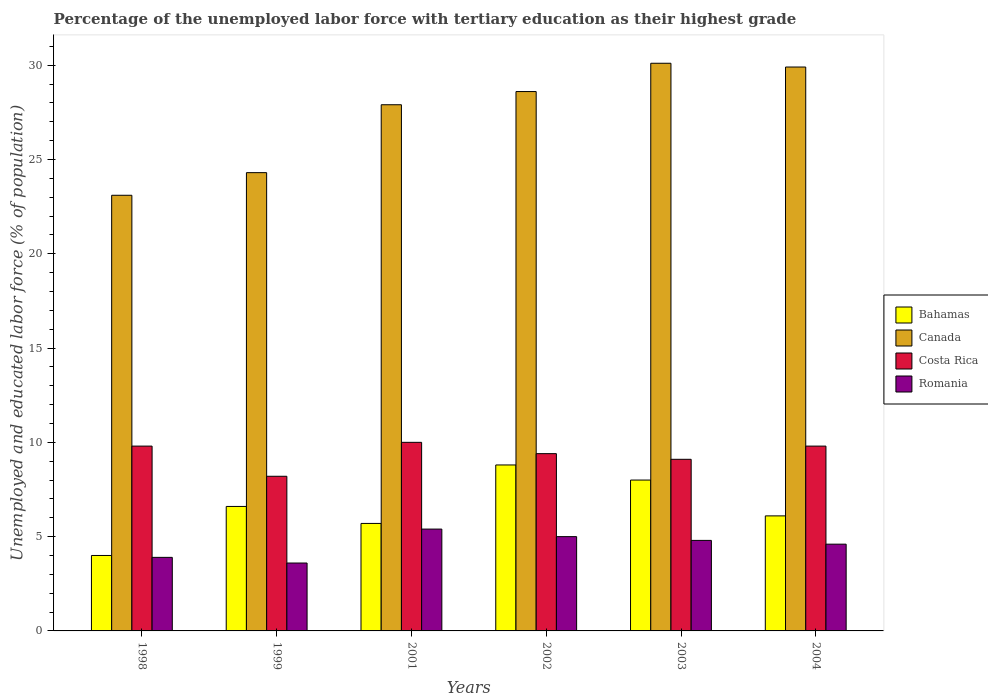How many groups of bars are there?
Your answer should be compact. 6. How many bars are there on the 2nd tick from the left?
Ensure brevity in your answer.  4. What is the label of the 3rd group of bars from the left?
Keep it short and to the point. 2001. In how many cases, is the number of bars for a given year not equal to the number of legend labels?
Offer a very short reply. 0. What is the percentage of the unemployed labor force with tertiary education in Canada in 2004?
Your answer should be very brief. 29.9. Across all years, what is the maximum percentage of the unemployed labor force with tertiary education in Canada?
Make the answer very short. 30.1. Across all years, what is the minimum percentage of the unemployed labor force with tertiary education in Romania?
Provide a succinct answer. 3.6. In which year was the percentage of the unemployed labor force with tertiary education in Romania minimum?
Your answer should be very brief. 1999. What is the total percentage of the unemployed labor force with tertiary education in Costa Rica in the graph?
Ensure brevity in your answer.  56.3. What is the difference between the percentage of the unemployed labor force with tertiary education in Costa Rica in 1998 and that in 1999?
Offer a very short reply. 1.6. What is the difference between the percentage of the unemployed labor force with tertiary education in Romania in 2001 and the percentage of the unemployed labor force with tertiary education in Costa Rica in 2002?
Your answer should be compact. -4. What is the average percentage of the unemployed labor force with tertiary education in Bahamas per year?
Offer a terse response. 6.53. In the year 2002, what is the difference between the percentage of the unemployed labor force with tertiary education in Bahamas and percentage of the unemployed labor force with tertiary education in Canada?
Your response must be concise. -19.8. In how many years, is the percentage of the unemployed labor force with tertiary education in Bahamas greater than 23 %?
Provide a short and direct response. 0. What is the ratio of the percentage of the unemployed labor force with tertiary education in Bahamas in 1998 to that in 2004?
Your response must be concise. 0.66. Is the percentage of the unemployed labor force with tertiary education in Bahamas in 1998 less than that in 2001?
Offer a very short reply. Yes. Is the difference between the percentage of the unemployed labor force with tertiary education in Bahamas in 1998 and 2003 greater than the difference between the percentage of the unemployed labor force with tertiary education in Canada in 1998 and 2003?
Provide a short and direct response. Yes. What is the difference between the highest and the second highest percentage of the unemployed labor force with tertiary education in Romania?
Offer a terse response. 0.4. What is the difference between the highest and the lowest percentage of the unemployed labor force with tertiary education in Costa Rica?
Provide a succinct answer. 1.8. Is the sum of the percentage of the unemployed labor force with tertiary education in Canada in 1999 and 2001 greater than the maximum percentage of the unemployed labor force with tertiary education in Bahamas across all years?
Provide a succinct answer. Yes. Is it the case that in every year, the sum of the percentage of the unemployed labor force with tertiary education in Costa Rica and percentage of the unemployed labor force with tertiary education in Canada is greater than the sum of percentage of the unemployed labor force with tertiary education in Bahamas and percentage of the unemployed labor force with tertiary education in Romania?
Your answer should be compact. No. What does the 1st bar from the left in 2001 represents?
Your answer should be compact. Bahamas. What does the 3rd bar from the right in 1998 represents?
Offer a very short reply. Canada. Is it the case that in every year, the sum of the percentage of the unemployed labor force with tertiary education in Costa Rica and percentage of the unemployed labor force with tertiary education in Bahamas is greater than the percentage of the unemployed labor force with tertiary education in Romania?
Your response must be concise. Yes. How many years are there in the graph?
Your answer should be very brief. 6. What is the difference between two consecutive major ticks on the Y-axis?
Provide a short and direct response. 5. Does the graph contain any zero values?
Your answer should be very brief. No. How many legend labels are there?
Your answer should be compact. 4. What is the title of the graph?
Keep it short and to the point. Percentage of the unemployed labor force with tertiary education as their highest grade. What is the label or title of the Y-axis?
Your answer should be compact. Unemployed and educated labor force (% of population). What is the Unemployed and educated labor force (% of population) in Bahamas in 1998?
Offer a terse response. 4. What is the Unemployed and educated labor force (% of population) in Canada in 1998?
Make the answer very short. 23.1. What is the Unemployed and educated labor force (% of population) of Costa Rica in 1998?
Your response must be concise. 9.8. What is the Unemployed and educated labor force (% of population) in Romania in 1998?
Give a very brief answer. 3.9. What is the Unemployed and educated labor force (% of population) of Bahamas in 1999?
Provide a succinct answer. 6.6. What is the Unemployed and educated labor force (% of population) in Canada in 1999?
Provide a short and direct response. 24.3. What is the Unemployed and educated labor force (% of population) in Costa Rica in 1999?
Provide a succinct answer. 8.2. What is the Unemployed and educated labor force (% of population) of Romania in 1999?
Your answer should be very brief. 3.6. What is the Unemployed and educated labor force (% of population) of Bahamas in 2001?
Ensure brevity in your answer.  5.7. What is the Unemployed and educated labor force (% of population) in Canada in 2001?
Ensure brevity in your answer.  27.9. What is the Unemployed and educated labor force (% of population) in Romania in 2001?
Keep it short and to the point. 5.4. What is the Unemployed and educated labor force (% of population) of Bahamas in 2002?
Your answer should be compact. 8.8. What is the Unemployed and educated labor force (% of population) of Canada in 2002?
Provide a succinct answer. 28.6. What is the Unemployed and educated labor force (% of population) in Costa Rica in 2002?
Provide a short and direct response. 9.4. What is the Unemployed and educated labor force (% of population) of Canada in 2003?
Make the answer very short. 30.1. What is the Unemployed and educated labor force (% of population) in Costa Rica in 2003?
Give a very brief answer. 9.1. What is the Unemployed and educated labor force (% of population) of Romania in 2003?
Ensure brevity in your answer.  4.8. What is the Unemployed and educated labor force (% of population) of Bahamas in 2004?
Ensure brevity in your answer.  6.1. What is the Unemployed and educated labor force (% of population) of Canada in 2004?
Your response must be concise. 29.9. What is the Unemployed and educated labor force (% of population) in Costa Rica in 2004?
Make the answer very short. 9.8. What is the Unemployed and educated labor force (% of population) in Romania in 2004?
Your response must be concise. 4.6. Across all years, what is the maximum Unemployed and educated labor force (% of population) in Bahamas?
Your response must be concise. 8.8. Across all years, what is the maximum Unemployed and educated labor force (% of population) in Canada?
Provide a short and direct response. 30.1. Across all years, what is the maximum Unemployed and educated labor force (% of population) of Romania?
Make the answer very short. 5.4. Across all years, what is the minimum Unemployed and educated labor force (% of population) in Bahamas?
Your answer should be very brief. 4. Across all years, what is the minimum Unemployed and educated labor force (% of population) of Canada?
Make the answer very short. 23.1. Across all years, what is the minimum Unemployed and educated labor force (% of population) in Costa Rica?
Provide a short and direct response. 8.2. Across all years, what is the minimum Unemployed and educated labor force (% of population) in Romania?
Your response must be concise. 3.6. What is the total Unemployed and educated labor force (% of population) of Bahamas in the graph?
Provide a succinct answer. 39.2. What is the total Unemployed and educated labor force (% of population) of Canada in the graph?
Give a very brief answer. 163.9. What is the total Unemployed and educated labor force (% of population) of Costa Rica in the graph?
Provide a short and direct response. 56.3. What is the total Unemployed and educated labor force (% of population) in Romania in the graph?
Make the answer very short. 27.3. What is the difference between the Unemployed and educated labor force (% of population) of Bahamas in 1998 and that in 1999?
Your answer should be compact. -2.6. What is the difference between the Unemployed and educated labor force (% of population) in Canada in 1998 and that in 1999?
Offer a terse response. -1.2. What is the difference between the Unemployed and educated labor force (% of population) of Costa Rica in 1998 and that in 1999?
Provide a short and direct response. 1.6. What is the difference between the Unemployed and educated labor force (% of population) of Romania in 1998 and that in 1999?
Provide a succinct answer. 0.3. What is the difference between the Unemployed and educated labor force (% of population) of Bahamas in 1998 and that in 2001?
Ensure brevity in your answer.  -1.7. What is the difference between the Unemployed and educated labor force (% of population) in Canada in 1998 and that in 2001?
Give a very brief answer. -4.8. What is the difference between the Unemployed and educated labor force (% of population) of Romania in 1998 and that in 2001?
Give a very brief answer. -1.5. What is the difference between the Unemployed and educated labor force (% of population) in Costa Rica in 1998 and that in 2003?
Make the answer very short. 0.7. What is the difference between the Unemployed and educated labor force (% of population) in Romania in 1998 and that in 2003?
Provide a succinct answer. -0.9. What is the difference between the Unemployed and educated labor force (% of population) of Bahamas in 1998 and that in 2004?
Offer a very short reply. -2.1. What is the difference between the Unemployed and educated labor force (% of population) of Canada in 1998 and that in 2004?
Your response must be concise. -6.8. What is the difference between the Unemployed and educated labor force (% of population) of Romania in 1998 and that in 2004?
Offer a very short reply. -0.7. What is the difference between the Unemployed and educated labor force (% of population) in Bahamas in 1999 and that in 2001?
Keep it short and to the point. 0.9. What is the difference between the Unemployed and educated labor force (% of population) of Romania in 1999 and that in 2001?
Offer a terse response. -1.8. What is the difference between the Unemployed and educated labor force (% of population) of Bahamas in 1999 and that in 2002?
Your answer should be compact. -2.2. What is the difference between the Unemployed and educated labor force (% of population) in Romania in 1999 and that in 2002?
Give a very brief answer. -1.4. What is the difference between the Unemployed and educated labor force (% of population) in Bahamas in 1999 and that in 2003?
Provide a short and direct response. -1.4. What is the difference between the Unemployed and educated labor force (% of population) in Costa Rica in 1999 and that in 2003?
Your answer should be very brief. -0.9. What is the difference between the Unemployed and educated labor force (% of population) in Romania in 1999 and that in 2003?
Provide a succinct answer. -1.2. What is the difference between the Unemployed and educated labor force (% of population) in Bahamas in 1999 and that in 2004?
Your answer should be compact. 0.5. What is the difference between the Unemployed and educated labor force (% of population) of Canada in 1999 and that in 2004?
Your answer should be compact. -5.6. What is the difference between the Unemployed and educated labor force (% of population) in Bahamas in 2001 and that in 2002?
Provide a succinct answer. -3.1. What is the difference between the Unemployed and educated labor force (% of population) in Canada in 2001 and that in 2003?
Provide a short and direct response. -2.2. What is the difference between the Unemployed and educated labor force (% of population) in Costa Rica in 2001 and that in 2003?
Your answer should be very brief. 0.9. What is the difference between the Unemployed and educated labor force (% of population) of Romania in 2001 and that in 2003?
Your answer should be very brief. 0.6. What is the difference between the Unemployed and educated labor force (% of population) of Bahamas in 2001 and that in 2004?
Your response must be concise. -0.4. What is the difference between the Unemployed and educated labor force (% of population) in Canada in 2002 and that in 2004?
Offer a terse response. -1.3. What is the difference between the Unemployed and educated labor force (% of population) in Costa Rica in 2002 and that in 2004?
Give a very brief answer. -0.4. What is the difference between the Unemployed and educated labor force (% of population) in Romania in 2002 and that in 2004?
Offer a very short reply. 0.4. What is the difference between the Unemployed and educated labor force (% of population) in Canada in 2003 and that in 2004?
Offer a terse response. 0.2. What is the difference between the Unemployed and educated labor force (% of population) of Bahamas in 1998 and the Unemployed and educated labor force (% of population) of Canada in 1999?
Your answer should be very brief. -20.3. What is the difference between the Unemployed and educated labor force (% of population) of Bahamas in 1998 and the Unemployed and educated labor force (% of population) of Romania in 1999?
Your response must be concise. 0.4. What is the difference between the Unemployed and educated labor force (% of population) in Canada in 1998 and the Unemployed and educated labor force (% of population) in Costa Rica in 1999?
Offer a very short reply. 14.9. What is the difference between the Unemployed and educated labor force (% of population) of Costa Rica in 1998 and the Unemployed and educated labor force (% of population) of Romania in 1999?
Provide a short and direct response. 6.2. What is the difference between the Unemployed and educated labor force (% of population) in Bahamas in 1998 and the Unemployed and educated labor force (% of population) in Canada in 2001?
Your response must be concise. -23.9. What is the difference between the Unemployed and educated labor force (% of population) in Bahamas in 1998 and the Unemployed and educated labor force (% of population) in Romania in 2001?
Give a very brief answer. -1.4. What is the difference between the Unemployed and educated labor force (% of population) in Canada in 1998 and the Unemployed and educated labor force (% of population) in Costa Rica in 2001?
Make the answer very short. 13.1. What is the difference between the Unemployed and educated labor force (% of population) of Bahamas in 1998 and the Unemployed and educated labor force (% of population) of Canada in 2002?
Give a very brief answer. -24.6. What is the difference between the Unemployed and educated labor force (% of population) in Canada in 1998 and the Unemployed and educated labor force (% of population) in Costa Rica in 2002?
Your response must be concise. 13.7. What is the difference between the Unemployed and educated labor force (% of population) in Costa Rica in 1998 and the Unemployed and educated labor force (% of population) in Romania in 2002?
Keep it short and to the point. 4.8. What is the difference between the Unemployed and educated labor force (% of population) of Bahamas in 1998 and the Unemployed and educated labor force (% of population) of Canada in 2003?
Offer a terse response. -26.1. What is the difference between the Unemployed and educated labor force (% of population) in Bahamas in 1998 and the Unemployed and educated labor force (% of population) in Costa Rica in 2003?
Keep it short and to the point. -5.1. What is the difference between the Unemployed and educated labor force (% of population) in Bahamas in 1998 and the Unemployed and educated labor force (% of population) in Romania in 2003?
Your answer should be very brief. -0.8. What is the difference between the Unemployed and educated labor force (% of population) of Canada in 1998 and the Unemployed and educated labor force (% of population) of Romania in 2003?
Keep it short and to the point. 18.3. What is the difference between the Unemployed and educated labor force (% of population) of Bahamas in 1998 and the Unemployed and educated labor force (% of population) of Canada in 2004?
Provide a succinct answer. -25.9. What is the difference between the Unemployed and educated labor force (% of population) of Bahamas in 1998 and the Unemployed and educated labor force (% of population) of Romania in 2004?
Keep it short and to the point. -0.6. What is the difference between the Unemployed and educated labor force (% of population) in Canada in 1998 and the Unemployed and educated labor force (% of population) in Costa Rica in 2004?
Make the answer very short. 13.3. What is the difference between the Unemployed and educated labor force (% of population) in Bahamas in 1999 and the Unemployed and educated labor force (% of population) in Canada in 2001?
Your answer should be compact. -21.3. What is the difference between the Unemployed and educated labor force (% of population) in Bahamas in 1999 and the Unemployed and educated labor force (% of population) in Costa Rica in 2001?
Your answer should be very brief. -3.4. What is the difference between the Unemployed and educated labor force (% of population) in Bahamas in 1999 and the Unemployed and educated labor force (% of population) in Romania in 2001?
Your answer should be compact. 1.2. What is the difference between the Unemployed and educated labor force (% of population) of Canada in 1999 and the Unemployed and educated labor force (% of population) of Romania in 2001?
Your response must be concise. 18.9. What is the difference between the Unemployed and educated labor force (% of population) in Bahamas in 1999 and the Unemployed and educated labor force (% of population) in Costa Rica in 2002?
Provide a succinct answer. -2.8. What is the difference between the Unemployed and educated labor force (% of population) of Bahamas in 1999 and the Unemployed and educated labor force (% of population) of Romania in 2002?
Keep it short and to the point. 1.6. What is the difference between the Unemployed and educated labor force (% of population) in Canada in 1999 and the Unemployed and educated labor force (% of population) in Costa Rica in 2002?
Provide a short and direct response. 14.9. What is the difference between the Unemployed and educated labor force (% of population) in Canada in 1999 and the Unemployed and educated labor force (% of population) in Romania in 2002?
Make the answer very short. 19.3. What is the difference between the Unemployed and educated labor force (% of population) in Bahamas in 1999 and the Unemployed and educated labor force (% of population) in Canada in 2003?
Provide a short and direct response. -23.5. What is the difference between the Unemployed and educated labor force (% of population) in Bahamas in 1999 and the Unemployed and educated labor force (% of population) in Costa Rica in 2003?
Provide a short and direct response. -2.5. What is the difference between the Unemployed and educated labor force (% of population) of Canada in 1999 and the Unemployed and educated labor force (% of population) of Costa Rica in 2003?
Provide a short and direct response. 15.2. What is the difference between the Unemployed and educated labor force (% of population) of Canada in 1999 and the Unemployed and educated labor force (% of population) of Romania in 2003?
Your answer should be very brief. 19.5. What is the difference between the Unemployed and educated labor force (% of population) of Costa Rica in 1999 and the Unemployed and educated labor force (% of population) of Romania in 2003?
Ensure brevity in your answer.  3.4. What is the difference between the Unemployed and educated labor force (% of population) in Bahamas in 1999 and the Unemployed and educated labor force (% of population) in Canada in 2004?
Provide a succinct answer. -23.3. What is the difference between the Unemployed and educated labor force (% of population) in Canada in 1999 and the Unemployed and educated labor force (% of population) in Romania in 2004?
Provide a succinct answer. 19.7. What is the difference between the Unemployed and educated labor force (% of population) of Costa Rica in 1999 and the Unemployed and educated labor force (% of population) of Romania in 2004?
Provide a succinct answer. 3.6. What is the difference between the Unemployed and educated labor force (% of population) of Bahamas in 2001 and the Unemployed and educated labor force (% of population) of Canada in 2002?
Provide a short and direct response. -22.9. What is the difference between the Unemployed and educated labor force (% of population) in Bahamas in 2001 and the Unemployed and educated labor force (% of population) in Romania in 2002?
Your answer should be compact. 0.7. What is the difference between the Unemployed and educated labor force (% of population) of Canada in 2001 and the Unemployed and educated labor force (% of population) of Romania in 2002?
Keep it short and to the point. 22.9. What is the difference between the Unemployed and educated labor force (% of population) of Bahamas in 2001 and the Unemployed and educated labor force (% of population) of Canada in 2003?
Offer a very short reply. -24.4. What is the difference between the Unemployed and educated labor force (% of population) in Bahamas in 2001 and the Unemployed and educated labor force (% of population) in Romania in 2003?
Your response must be concise. 0.9. What is the difference between the Unemployed and educated labor force (% of population) in Canada in 2001 and the Unemployed and educated labor force (% of population) in Costa Rica in 2003?
Your response must be concise. 18.8. What is the difference between the Unemployed and educated labor force (% of population) in Canada in 2001 and the Unemployed and educated labor force (% of population) in Romania in 2003?
Make the answer very short. 23.1. What is the difference between the Unemployed and educated labor force (% of population) of Bahamas in 2001 and the Unemployed and educated labor force (% of population) of Canada in 2004?
Make the answer very short. -24.2. What is the difference between the Unemployed and educated labor force (% of population) in Canada in 2001 and the Unemployed and educated labor force (% of population) in Costa Rica in 2004?
Your answer should be very brief. 18.1. What is the difference between the Unemployed and educated labor force (% of population) of Canada in 2001 and the Unemployed and educated labor force (% of population) of Romania in 2004?
Your answer should be very brief. 23.3. What is the difference between the Unemployed and educated labor force (% of population) of Bahamas in 2002 and the Unemployed and educated labor force (% of population) of Canada in 2003?
Provide a succinct answer. -21.3. What is the difference between the Unemployed and educated labor force (% of population) of Canada in 2002 and the Unemployed and educated labor force (% of population) of Romania in 2003?
Provide a succinct answer. 23.8. What is the difference between the Unemployed and educated labor force (% of population) in Costa Rica in 2002 and the Unemployed and educated labor force (% of population) in Romania in 2003?
Offer a very short reply. 4.6. What is the difference between the Unemployed and educated labor force (% of population) in Bahamas in 2002 and the Unemployed and educated labor force (% of population) in Canada in 2004?
Provide a succinct answer. -21.1. What is the difference between the Unemployed and educated labor force (% of population) in Canada in 2002 and the Unemployed and educated labor force (% of population) in Costa Rica in 2004?
Offer a terse response. 18.8. What is the difference between the Unemployed and educated labor force (% of population) of Costa Rica in 2002 and the Unemployed and educated labor force (% of population) of Romania in 2004?
Make the answer very short. 4.8. What is the difference between the Unemployed and educated labor force (% of population) in Bahamas in 2003 and the Unemployed and educated labor force (% of population) in Canada in 2004?
Keep it short and to the point. -21.9. What is the difference between the Unemployed and educated labor force (% of population) of Bahamas in 2003 and the Unemployed and educated labor force (% of population) of Costa Rica in 2004?
Make the answer very short. -1.8. What is the difference between the Unemployed and educated labor force (% of population) in Bahamas in 2003 and the Unemployed and educated labor force (% of population) in Romania in 2004?
Offer a terse response. 3.4. What is the difference between the Unemployed and educated labor force (% of population) of Canada in 2003 and the Unemployed and educated labor force (% of population) of Costa Rica in 2004?
Your response must be concise. 20.3. What is the average Unemployed and educated labor force (% of population) in Bahamas per year?
Your answer should be compact. 6.53. What is the average Unemployed and educated labor force (% of population) in Canada per year?
Offer a terse response. 27.32. What is the average Unemployed and educated labor force (% of population) of Costa Rica per year?
Give a very brief answer. 9.38. What is the average Unemployed and educated labor force (% of population) in Romania per year?
Your answer should be very brief. 4.55. In the year 1998, what is the difference between the Unemployed and educated labor force (% of population) of Bahamas and Unemployed and educated labor force (% of population) of Canada?
Your answer should be very brief. -19.1. In the year 1998, what is the difference between the Unemployed and educated labor force (% of population) in Bahamas and Unemployed and educated labor force (% of population) in Costa Rica?
Your answer should be very brief. -5.8. In the year 1998, what is the difference between the Unemployed and educated labor force (% of population) of Canada and Unemployed and educated labor force (% of population) of Costa Rica?
Your response must be concise. 13.3. In the year 1998, what is the difference between the Unemployed and educated labor force (% of population) of Canada and Unemployed and educated labor force (% of population) of Romania?
Offer a terse response. 19.2. In the year 1998, what is the difference between the Unemployed and educated labor force (% of population) in Costa Rica and Unemployed and educated labor force (% of population) in Romania?
Your answer should be very brief. 5.9. In the year 1999, what is the difference between the Unemployed and educated labor force (% of population) in Bahamas and Unemployed and educated labor force (% of population) in Canada?
Ensure brevity in your answer.  -17.7. In the year 1999, what is the difference between the Unemployed and educated labor force (% of population) of Bahamas and Unemployed and educated labor force (% of population) of Costa Rica?
Give a very brief answer. -1.6. In the year 1999, what is the difference between the Unemployed and educated labor force (% of population) in Bahamas and Unemployed and educated labor force (% of population) in Romania?
Give a very brief answer. 3. In the year 1999, what is the difference between the Unemployed and educated labor force (% of population) of Canada and Unemployed and educated labor force (% of population) of Romania?
Make the answer very short. 20.7. In the year 1999, what is the difference between the Unemployed and educated labor force (% of population) in Costa Rica and Unemployed and educated labor force (% of population) in Romania?
Make the answer very short. 4.6. In the year 2001, what is the difference between the Unemployed and educated labor force (% of population) of Bahamas and Unemployed and educated labor force (% of population) of Canada?
Offer a very short reply. -22.2. In the year 2001, what is the difference between the Unemployed and educated labor force (% of population) in Bahamas and Unemployed and educated labor force (% of population) in Costa Rica?
Your answer should be very brief. -4.3. In the year 2001, what is the difference between the Unemployed and educated labor force (% of population) in Bahamas and Unemployed and educated labor force (% of population) in Romania?
Provide a short and direct response. 0.3. In the year 2001, what is the difference between the Unemployed and educated labor force (% of population) of Canada and Unemployed and educated labor force (% of population) of Romania?
Your answer should be compact. 22.5. In the year 2002, what is the difference between the Unemployed and educated labor force (% of population) of Bahamas and Unemployed and educated labor force (% of population) of Canada?
Make the answer very short. -19.8. In the year 2002, what is the difference between the Unemployed and educated labor force (% of population) in Bahamas and Unemployed and educated labor force (% of population) in Romania?
Make the answer very short. 3.8. In the year 2002, what is the difference between the Unemployed and educated labor force (% of population) of Canada and Unemployed and educated labor force (% of population) of Costa Rica?
Provide a short and direct response. 19.2. In the year 2002, what is the difference between the Unemployed and educated labor force (% of population) of Canada and Unemployed and educated labor force (% of population) of Romania?
Your answer should be very brief. 23.6. In the year 2003, what is the difference between the Unemployed and educated labor force (% of population) in Bahamas and Unemployed and educated labor force (% of population) in Canada?
Your answer should be compact. -22.1. In the year 2003, what is the difference between the Unemployed and educated labor force (% of population) in Bahamas and Unemployed and educated labor force (% of population) in Costa Rica?
Your answer should be very brief. -1.1. In the year 2003, what is the difference between the Unemployed and educated labor force (% of population) in Bahamas and Unemployed and educated labor force (% of population) in Romania?
Offer a terse response. 3.2. In the year 2003, what is the difference between the Unemployed and educated labor force (% of population) of Canada and Unemployed and educated labor force (% of population) of Costa Rica?
Your answer should be very brief. 21. In the year 2003, what is the difference between the Unemployed and educated labor force (% of population) in Canada and Unemployed and educated labor force (% of population) in Romania?
Provide a succinct answer. 25.3. In the year 2004, what is the difference between the Unemployed and educated labor force (% of population) in Bahamas and Unemployed and educated labor force (% of population) in Canada?
Provide a succinct answer. -23.8. In the year 2004, what is the difference between the Unemployed and educated labor force (% of population) of Bahamas and Unemployed and educated labor force (% of population) of Romania?
Ensure brevity in your answer.  1.5. In the year 2004, what is the difference between the Unemployed and educated labor force (% of population) of Canada and Unemployed and educated labor force (% of population) of Costa Rica?
Make the answer very short. 20.1. In the year 2004, what is the difference between the Unemployed and educated labor force (% of population) in Canada and Unemployed and educated labor force (% of population) in Romania?
Ensure brevity in your answer.  25.3. What is the ratio of the Unemployed and educated labor force (% of population) in Bahamas in 1998 to that in 1999?
Provide a short and direct response. 0.61. What is the ratio of the Unemployed and educated labor force (% of population) in Canada in 1998 to that in 1999?
Offer a terse response. 0.95. What is the ratio of the Unemployed and educated labor force (% of population) in Costa Rica in 1998 to that in 1999?
Make the answer very short. 1.2. What is the ratio of the Unemployed and educated labor force (% of population) of Romania in 1998 to that in 1999?
Give a very brief answer. 1.08. What is the ratio of the Unemployed and educated labor force (% of population) in Bahamas in 1998 to that in 2001?
Offer a very short reply. 0.7. What is the ratio of the Unemployed and educated labor force (% of population) of Canada in 1998 to that in 2001?
Your answer should be compact. 0.83. What is the ratio of the Unemployed and educated labor force (% of population) of Costa Rica in 1998 to that in 2001?
Give a very brief answer. 0.98. What is the ratio of the Unemployed and educated labor force (% of population) in Romania in 1998 to that in 2001?
Your answer should be very brief. 0.72. What is the ratio of the Unemployed and educated labor force (% of population) of Bahamas in 1998 to that in 2002?
Your response must be concise. 0.45. What is the ratio of the Unemployed and educated labor force (% of population) in Canada in 1998 to that in 2002?
Your response must be concise. 0.81. What is the ratio of the Unemployed and educated labor force (% of population) in Costa Rica in 1998 to that in 2002?
Offer a terse response. 1.04. What is the ratio of the Unemployed and educated labor force (% of population) of Romania in 1998 to that in 2002?
Keep it short and to the point. 0.78. What is the ratio of the Unemployed and educated labor force (% of population) in Bahamas in 1998 to that in 2003?
Provide a short and direct response. 0.5. What is the ratio of the Unemployed and educated labor force (% of population) in Canada in 1998 to that in 2003?
Ensure brevity in your answer.  0.77. What is the ratio of the Unemployed and educated labor force (% of population) of Costa Rica in 1998 to that in 2003?
Your answer should be compact. 1.08. What is the ratio of the Unemployed and educated labor force (% of population) in Romania in 1998 to that in 2003?
Offer a terse response. 0.81. What is the ratio of the Unemployed and educated labor force (% of population) in Bahamas in 1998 to that in 2004?
Provide a short and direct response. 0.66. What is the ratio of the Unemployed and educated labor force (% of population) of Canada in 1998 to that in 2004?
Offer a very short reply. 0.77. What is the ratio of the Unemployed and educated labor force (% of population) of Costa Rica in 1998 to that in 2004?
Provide a succinct answer. 1. What is the ratio of the Unemployed and educated labor force (% of population) in Romania in 1998 to that in 2004?
Offer a very short reply. 0.85. What is the ratio of the Unemployed and educated labor force (% of population) in Bahamas in 1999 to that in 2001?
Make the answer very short. 1.16. What is the ratio of the Unemployed and educated labor force (% of population) of Canada in 1999 to that in 2001?
Make the answer very short. 0.87. What is the ratio of the Unemployed and educated labor force (% of population) of Costa Rica in 1999 to that in 2001?
Ensure brevity in your answer.  0.82. What is the ratio of the Unemployed and educated labor force (% of population) in Canada in 1999 to that in 2002?
Keep it short and to the point. 0.85. What is the ratio of the Unemployed and educated labor force (% of population) of Costa Rica in 1999 to that in 2002?
Offer a terse response. 0.87. What is the ratio of the Unemployed and educated labor force (% of population) in Romania in 1999 to that in 2002?
Your answer should be very brief. 0.72. What is the ratio of the Unemployed and educated labor force (% of population) of Bahamas in 1999 to that in 2003?
Offer a very short reply. 0.82. What is the ratio of the Unemployed and educated labor force (% of population) in Canada in 1999 to that in 2003?
Ensure brevity in your answer.  0.81. What is the ratio of the Unemployed and educated labor force (% of population) of Costa Rica in 1999 to that in 2003?
Your answer should be very brief. 0.9. What is the ratio of the Unemployed and educated labor force (% of population) of Romania in 1999 to that in 2003?
Offer a very short reply. 0.75. What is the ratio of the Unemployed and educated labor force (% of population) in Bahamas in 1999 to that in 2004?
Offer a very short reply. 1.08. What is the ratio of the Unemployed and educated labor force (% of population) in Canada in 1999 to that in 2004?
Give a very brief answer. 0.81. What is the ratio of the Unemployed and educated labor force (% of population) of Costa Rica in 1999 to that in 2004?
Offer a terse response. 0.84. What is the ratio of the Unemployed and educated labor force (% of population) of Romania in 1999 to that in 2004?
Your answer should be very brief. 0.78. What is the ratio of the Unemployed and educated labor force (% of population) in Bahamas in 2001 to that in 2002?
Your answer should be very brief. 0.65. What is the ratio of the Unemployed and educated labor force (% of population) in Canada in 2001 to that in 2002?
Keep it short and to the point. 0.98. What is the ratio of the Unemployed and educated labor force (% of population) in Costa Rica in 2001 to that in 2002?
Your answer should be very brief. 1.06. What is the ratio of the Unemployed and educated labor force (% of population) in Romania in 2001 to that in 2002?
Your answer should be very brief. 1.08. What is the ratio of the Unemployed and educated labor force (% of population) in Bahamas in 2001 to that in 2003?
Offer a very short reply. 0.71. What is the ratio of the Unemployed and educated labor force (% of population) in Canada in 2001 to that in 2003?
Provide a succinct answer. 0.93. What is the ratio of the Unemployed and educated labor force (% of population) in Costa Rica in 2001 to that in 2003?
Provide a short and direct response. 1.1. What is the ratio of the Unemployed and educated labor force (% of population) of Romania in 2001 to that in 2003?
Give a very brief answer. 1.12. What is the ratio of the Unemployed and educated labor force (% of population) in Bahamas in 2001 to that in 2004?
Give a very brief answer. 0.93. What is the ratio of the Unemployed and educated labor force (% of population) in Canada in 2001 to that in 2004?
Provide a succinct answer. 0.93. What is the ratio of the Unemployed and educated labor force (% of population) in Costa Rica in 2001 to that in 2004?
Offer a very short reply. 1.02. What is the ratio of the Unemployed and educated labor force (% of population) in Romania in 2001 to that in 2004?
Your answer should be compact. 1.17. What is the ratio of the Unemployed and educated labor force (% of population) of Canada in 2002 to that in 2003?
Your answer should be very brief. 0.95. What is the ratio of the Unemployed and educated labor force (% of population) of Costa Rica in 2002 to that in 2003?
Your response must be concise. 1.03. What is the ratio of the Unemployed and educated labor force (% of population) in Romania in 2002 to that in 2003?
Your answer should be compact. 1.04. What is the ratio of the Unemployed and educated labor force (% of population) of Bahamas in 2002 to that in 2004?
Your answer should be very brief. 1.44. What is the ratio of the Unemployed and educated labor force (% of population) of Canada in 2002 to that in 2004?
Your answer should be compact. 0.96. What is the ratio of the Unemployed and educated labor force (% of population) in Costa Rica in 2002 to that in 2004?
Keep it short and to the point. 0.96. What is the ratio of the Unemployed and educated labor force (% of population) in Romania in 2002 to that in 2004?
Provide a short and direct response. 1.09. What is the ratio of the Unemployed and educated labor force (% of population) in Bahamas in 2003 to that in 2004?
Your answer should be very brief. 1.31. What is the ratio of the Unemployed and educated labor force (% of population) of Costa Rica in 2003 to that in 2004?
Your answer should be compact. 0.93. What is the ratio of the Unemployed and educated labor force (% of population) of Romania in 2003 to that in 2004?
Give a very brief answer. 1.04. What is the difference between the highest and the second highest Unemployed and educated labor force (% of population) in Costa Rica?
Offer a very short reply. 0.2. What is the difference between the highest and the lowest Unemployed and educated labor force (% of population) in Bahamas?
Provide a succinct answer. 4.8. What is the difference between the highest and the lowest Unemployed and educated labor force (% of population) of Canada?
Offer a very short reply. 7. What is the difference between the highest and the lowest Unemployed and educated labor force (% of population) in Costa Rica?
Make the answer very short. 1.8. What is the difference between the highest and the lowest Unemployed and educated labor force (% of population) of Romania?
Make the answer very short. 1.8. 